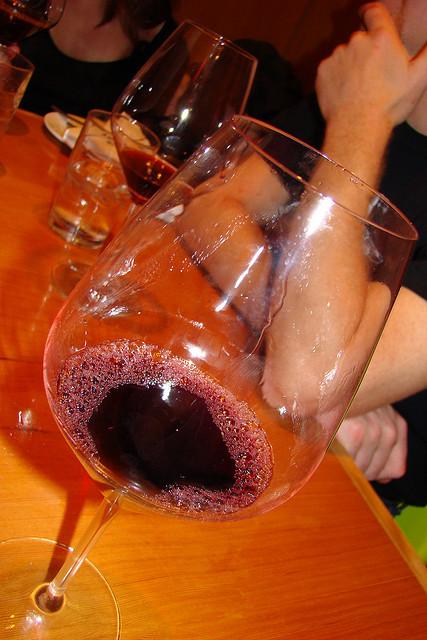Are those elbows on the table?
Quick response, please. Yes. What is inside of the glass?
Concise answer only. Wine. Is the glass nearly empty?
Be succinct. Yes. 